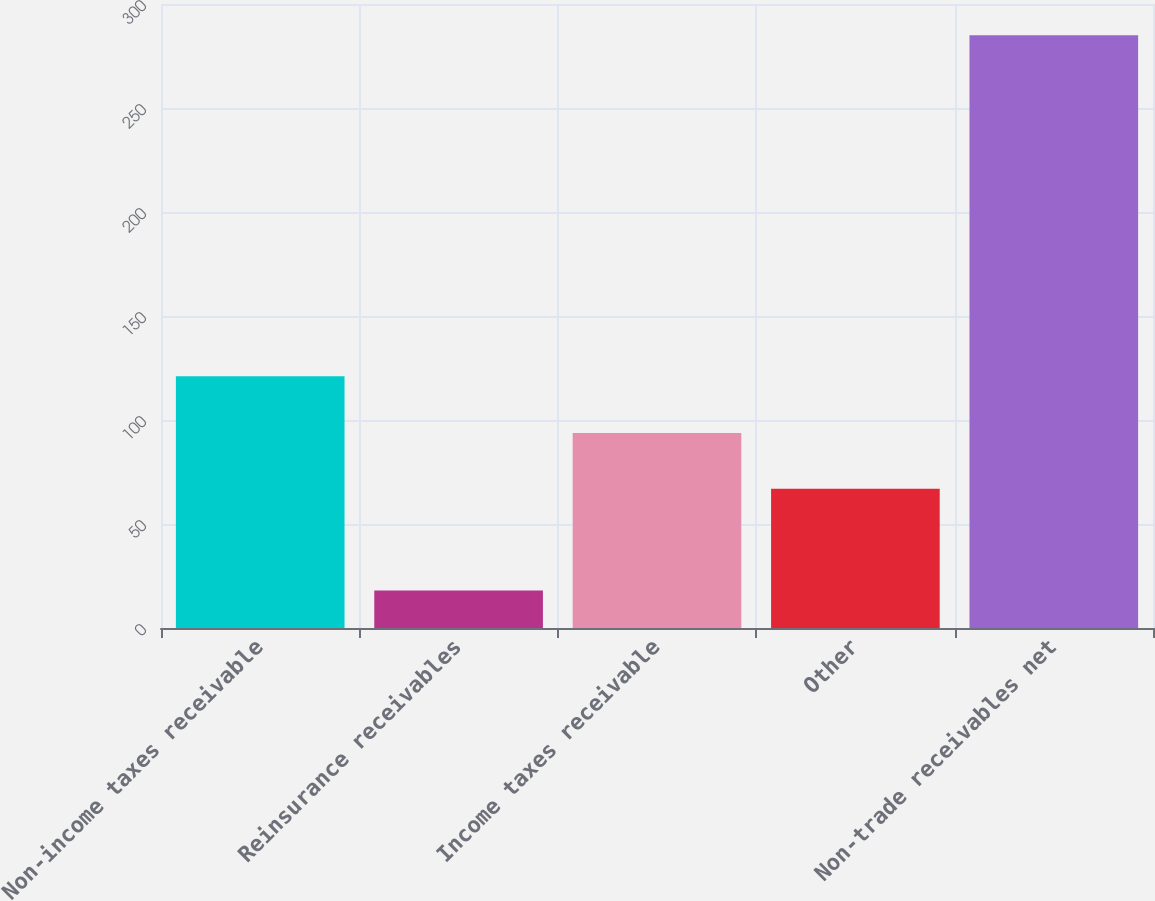<chart> <loc_0><loc_0><loc_500><loc_500><bar_chart><fcel>Non-income taxes receivable<fcel>Reinsurance receivables<fcel>Income taxes receivable<fcel>Other<fcel>Non-trade receivables net<nl><fcel>121<fcel>18<fcel>93.7<fcel>67<fcel>285<nl></chart> 